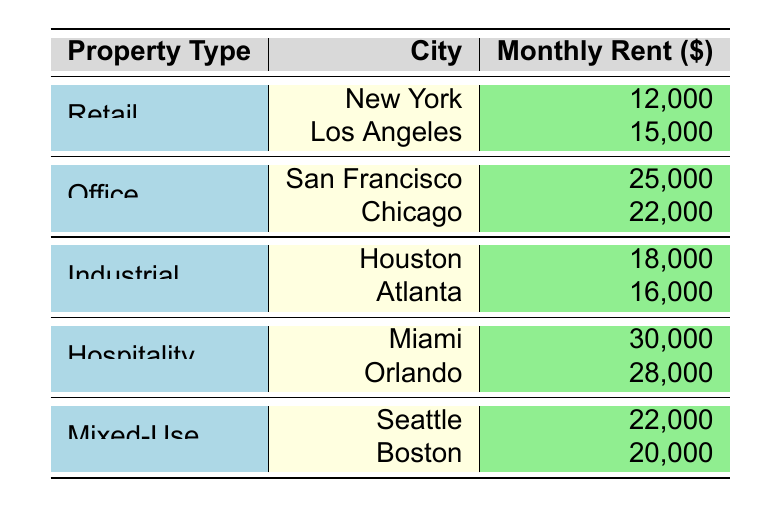What is the highest monthly rent recorded in the table? Looking at the listed monthly rents, the highest value is in Miami with a rent of 30,000.
Answer: 30,000 Which property type has the lowest average monthly rent? To calculate the average monthly rent for each property type, we must first aggregate the rents for each type and then divide by the number of locations. Retail: (12,000 + 15,000)/2 = 13,500, Office: (25,000 + 22,000)/2 = 23,500, Industrial: (18,000 + 16,000)/2 = 17,000, Hospitality: (30,000 + 28,000)/2 = 29,000, Mixed-Use: (22,000 + 20,000)/2 = 21,000. The lowest average is for Industrial at 17,000.
Answer: Industrial Is the monthly rent for Seattle higher than that for Chicago? The monthly rent for Seattle is 22,000, while Chicago's rent is 22,000. Since they are equal, we conclude that Seattle's rent is not higher than Chicago's.
Answer: No What is the total monthly rent across all commercial properties in New York? The table shows that there is only one property in New York under the Retail category with a rent of 12,000. Thus, the total in New York is simply the monthly rent of that property.
Answer: 12,000 Which property type has the most variation in monthly rent across different cities? To determine this, we calculate the difference between the highest and lowest monthly rent for each property type: Retail (15,000 - 12,000 = 3,000), Office (25,000 - 22,000 = 3,000), Industrial (18,000 - 16,000 = 2,000), Hospitality (30,000 - 28,000 = 2,000), Mixed-Use (22,000 - 20,000 = 2,000). Retail and Office both have a variation of 3,000, which is the highest.
Answer: Retail and Office 